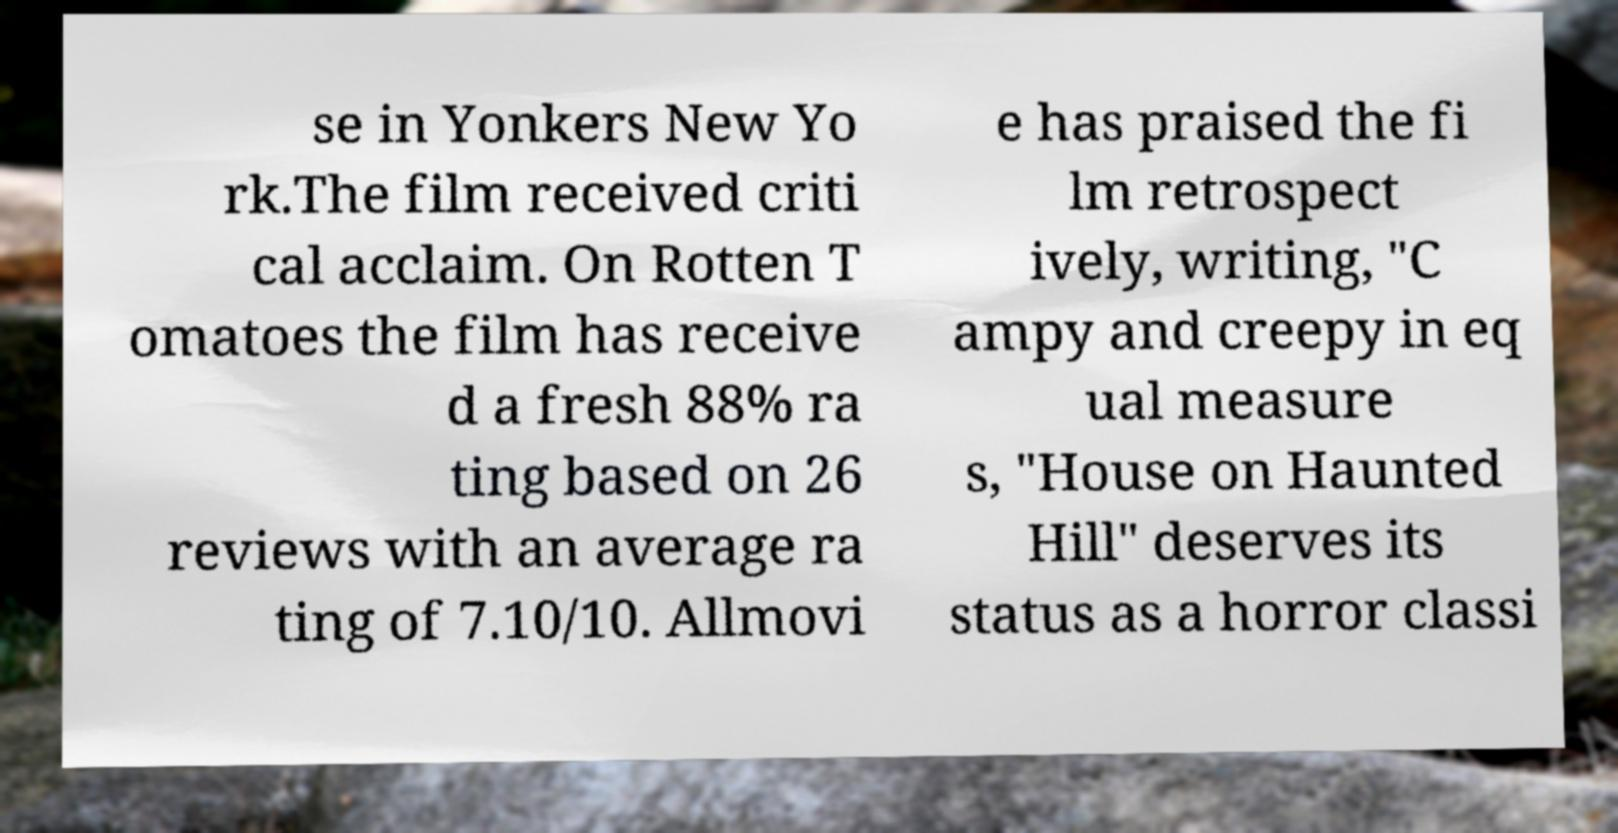Can you read and provide the text displayed in the image?This photo seems to have some interesting text. Can you extract and type it out for me? se in Yonkers New Yo rk.The film received criti cal acclaim. On Rotten T omatoes the film has receive d a fresh 88% ra ting based on 26 reviews with an average ra ting of 7.10/10. Allmovi e has praised the fi lm retrospect ively, writing, "C ampy and creepy in eq ual measure s, "House on Haunted Hill" deserves its status as a horror classi 